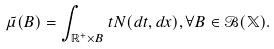<formula> <loc_0><loc_0><loc_500><loc_500>\tilde { \mu } ( B ) = \int _ { \mathbb { R } ^ { + } \times B } t N ( d t , d x ) , \forall B \in \mathcal { B } ( \mathbb { X } ) .</formula> 